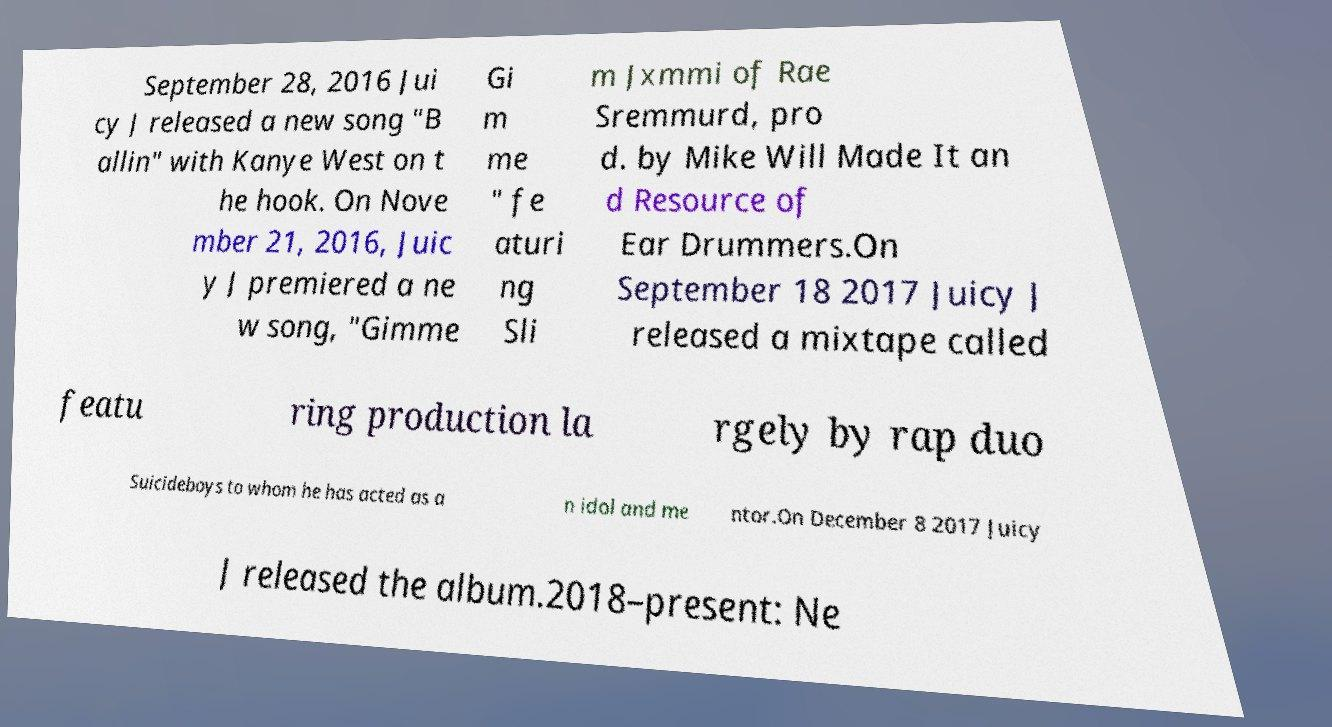I need the written content from this picture converted into text. Can you do that? September 28, 2016 Jui cy J released a new song "B allin" with Kanye West on t he hook. On Nove mber 21, 2016, Juic y J premiered a ne w song, "Gimme Gi m me " fe aturi ng Sli m Jxmmi of Rae Sremmurd, pro d. by Mike Will Made It an d Resource of Ear Drummers.On September 18 2017 Juicy J released a mixtape called featu ring production la rgely by rap duo Suicideboys to whom he has acted as a n idol and me ntor.On December 8 2017 Juicy J released the album.2018–present: Ne 